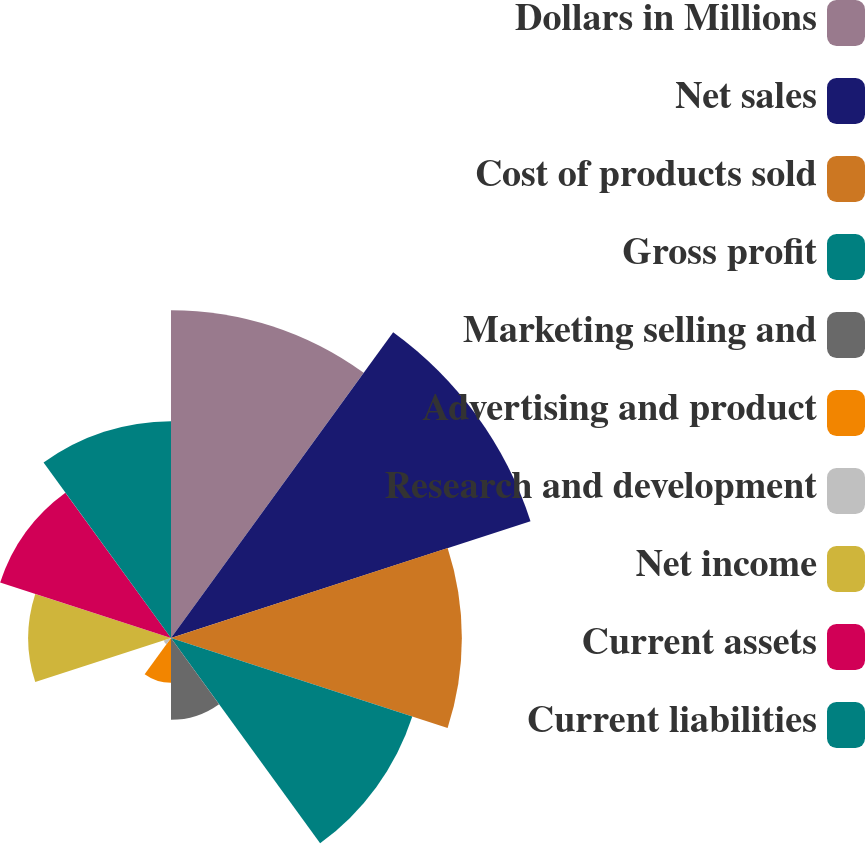<chart> <loc_0><loc_0><loc_500><loc_500><pie_chart><fcel>Dollars in Millions<fcel>Net sales<fcel>Cost of products sold<fcel>Gross profit<fcel>Marketing selling and<fcel>Advertising and product<fcel>Research and development<fcel>Net income<fcel>Current assets<fcel>Current liabilities<nl><fcel>17.04%<fcel>19.65%<fcel>15.12%<fcel>13.19%<fcel>4.25%<fcel>2.33%<fcel>0.4%<fcel>7.42%<fcel>9.34%<fcel>11.27%<nl></chart> 